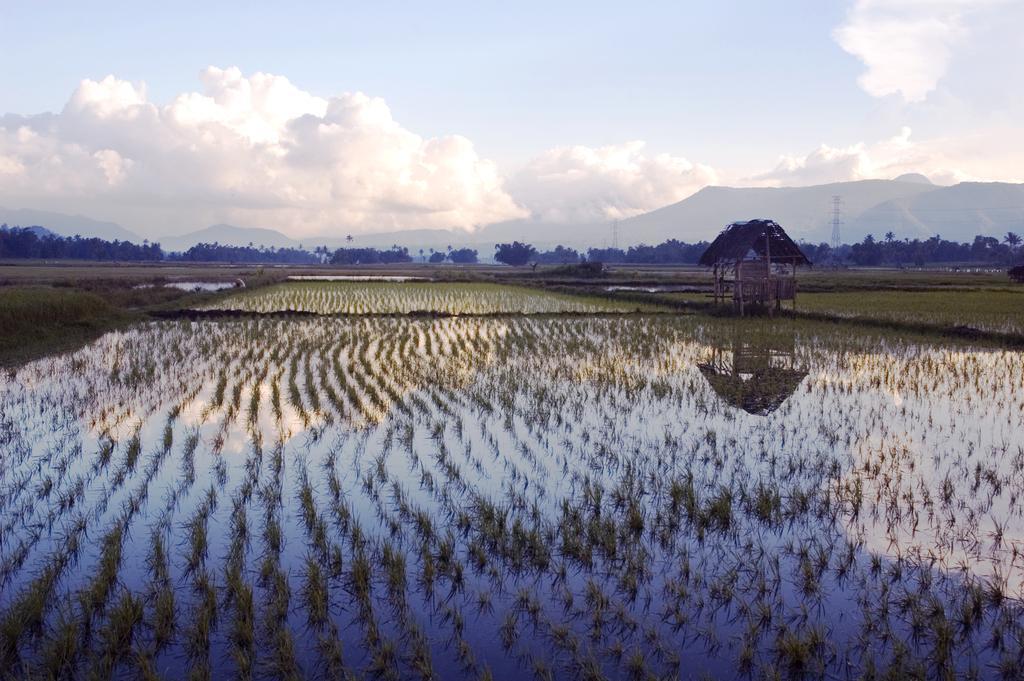Can you describe this image briefly? In this picture we can see water, few plants and a hut, in the background we can see few trees, hills, towers and clouds. 